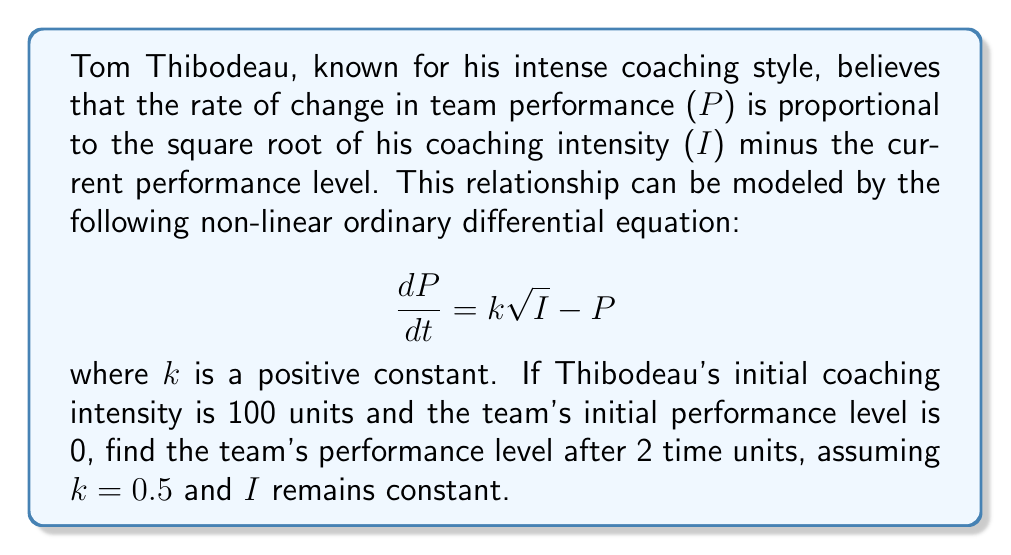Teach me how to tackle this problem. To solve this non-linear ODE, we'll follow these steps:

1) First, we recognize this as a first-order linear ODE in the form:

   $$ \frac{dP}{dt} + P = k\sqrt{I} $$

2) The general solution for this type of equation is:

   $$ P(t) = e^{-t} \int e^t k\sqrt{I} dt + Ce^{-t} $$

3) Since $I$ is constant (100), and $k = 0.5$, we can simplify:

   $$ P(t) = 0.5\sqrt{100} e^{-t} \int e^t dt + Ce^{-t} $$
   $$ P(t) = 5e^{-t} (e^t) + Ce^{-t} $$
   $$ P(t) = 5 + Ce^{-t} $$

4) To find $C$, we use the initial condition $P(0) = 0$:

   $$ 0 = 5 + C $$
   $$ C = -5 $$

5) Therefore, the particular solution is:

   $$ P(t) = 5 - 5e^{-t} $$

6) To find the performance level after 2 time units, we evaluate $P(2)$:

   $$ P(2) = 5 - 5e^{-2} $$
   $$ P(2) = 5 - 5(0.1353) $$
   $$ P(2) = 5 - 0.6765 $$
   $$ P(2) = 4.3235 $$

Thus, after 2 time units, the team's performance level will be approximately 4.3235 units.
Answer: The team's performance level after 2 time units is approximately 4.3235 units. 